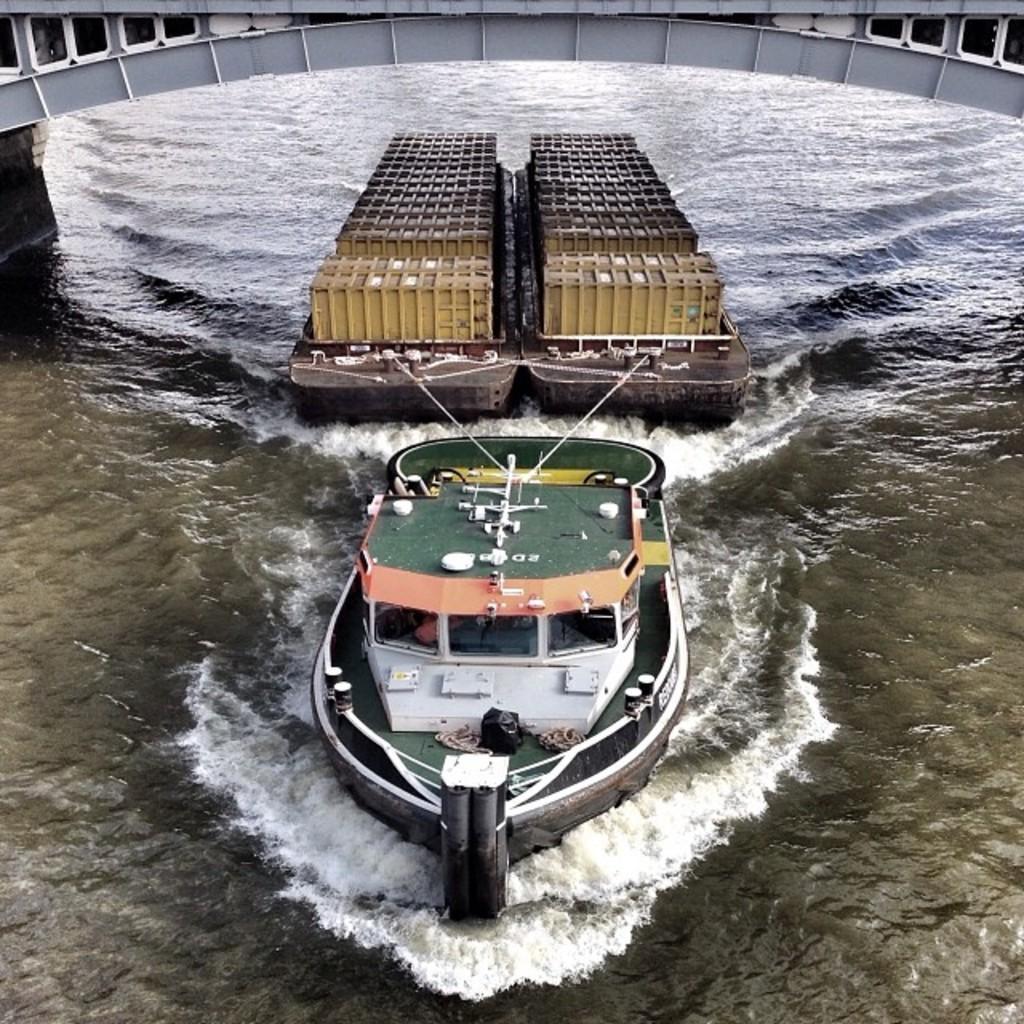Can you describe this image briefly? In this picture I can see the water on which there is a boat and I see 2 brown color things tied to the boats with the ropes and I can see few things on those brown color things. 